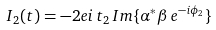Convert formula to latex. <formula><loc_0><loc_0><loc_500><loc_500>I _ { 2 } ( t ) = - 2 e i \, t _ { 2 } \, I m \{ \alpha ^ { * } \beta \, e ^ { - i \phi _ { 2 } } \}</formula> 